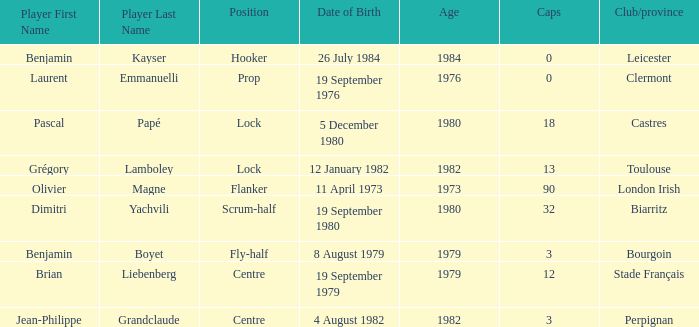Which athlete has a cap exceeding 12 and belongs to toulouse clubs? Grégory Lamboley. 